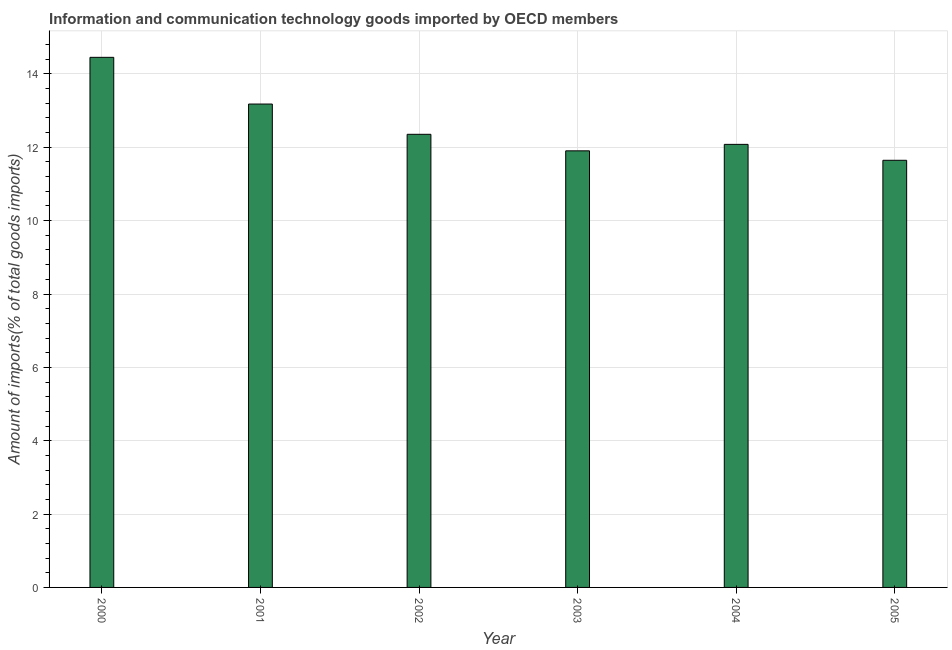Does the graph contain grids?
Offer a terse response. Yes. What is the title of the graph?
Give a very brief answer. Information and communication technology goods imported by OECD members. What is the label or title of the X-axis?
Provide a succinct answer. Year. What is the label or title of the Y-axis?
Keep it short and to the point. Amount of imports(% of total goods imports). What is the amount of ict goods imports in 2002?
Ensure brevity in your answer.  12.35. Across all years, what is the maximum amount of ict goods imports?
Give a very brief answer. 14.45. Across all years, what is the minimum amount of ict goods imports?
Make the answer very short. 11.65. In which year was the amount of ict goods imports maximum?
Provide a succinct answer. 2000. In which year was the amount of ict goods imports minimum?
Offer a terse response. 2005. What is the sum of the amount of ict goods imports?
Provide a short and direct response. 75.62. What is the difference between the amount of ict goods imports in 2001 and 2003?
Ensure brevity in your answer.  1.28. What is the average amount of ict goods imports per year?
Your answer should be compact. 12.6. What is the median amount of ict goods imports?
Your answer should be very brief. 12.22. What is the ratio of the amount of ict goods imports in 2002 to that in 2003?
Provide a short and direct response. 1.04. Is the difference between the amount of ict goods imports in 2002 and 2003 greater than the difference between any two years?
Offer a very short reply. No. What is the difference between the highest and the second highest amount of ict goods imports?
Your answer should be very brief. 1.27. What is the difference between the highest and the lowest amount of ict goods imports?
Offer a very short reply. 2.81. How many bars are there?
Offer a very short reply. 6. Are all the bars in the graph horizontal?
Give a very brief answer. No. How many years are there in the graph?
Your response must be concise. 6. Are the values on the major ticks of Y-axis written in scientific E-notation?
Ensure brevity in your answer.  No. What is the Amount of imports(% of total goods imports) of 2000?
Ensure brevity in your answer.  14.45. What is the Amount of imports(% of total goods imports) in 2001?
Your answer should be compact. 13.18. What is the Amount of imports(% of total goods imports) in 2002?
Keep it short and to the point. 12.35. What is the Amount of imports(% of total goods imports) of 2003?
Keep it short and to the point. 11.9. What is the Amount of imports(% of total goods imports) in 2004?
Make the answer very short. 12.08. What is the Amount of imports(% of total goods imports) in 2005?
Offer a very short reply. 11.65. What is the difference between the Amount of imports(% of total goods imports) in 2000 and 2001?
Give a very brief answer. 1.27. What is the difference between the Amount of imports(% of total goods imports) in 2000 and 2002?
Your response must be concise. 2.1. What is the difference between the Amount of imports(% of total goods imports) in 2000 and 2003?
Make the answer very short. 2.55. What is the difference between the Amount of imports(% of total goods imports) in 2000 and 2004?
Provide a succinct answer. 2.37. What is the difference between the Amount of imports(% of total goods imports) in 2000 and 2005?
Give a very brief answer. 2.81. What is the difference between the Amount of imports(% of total goods imports) in 2001 and 2002?
Give a very brief answer. 0.83. What is the difference between the Amount of imports(% of total goods imports) in 2001 and 2003?
Give a very brief answer. 1.28. What is the difference between the Amount of imports(% of total goods imports) in 2001 and 2004?
Your response must be concise. 1.1. What is the difference between the Amount of imports(% of total goods imports) in 2001 and 2005?
Ensure brevity in your answer.  1.53. What is the difference between the Amount of imports(% of total goods imports) in 2002 and 2003?
Offer a terse response. 0.45. What is the difference between the Amount of imports(% of total goods imports) in 2002 and 2004?
Your answer should be compact. 0.27. What is the difference between the Amount of imports(% of total goods imports) in 2002 and 2005?
Your answer should be very brief. 0.71. What is the difference between the Amount of imports(% of total goods imports) in 2003 and 2004?
Offer a terse response. -0.18. What is the difference between the Amount of imports(% of total goods imports) in 2003 and 2005?
Your response must be concise. 0.26. What is the difference between the Amount of imports(% of total goods imports) in 2004 and 2005?
Offer a terse response. 0.43. What is the ratio of the Amount of imports(% of total goods imports) in 2000 to that in 2001?
Make the answer very short. 1.1. What is the ratio of the Amount of imports(% of total goods imports) in 2000 to that in 2002?
Make the answer very short. 1.17. What is the ratio of the Amount of imports(% of total goods imports) in 2000 to that in 2003?
Make the answer very short. 1.21. What is the ratio of the Amount of imports(% of total goods imports) in 2000 to that in 2004?
Keep it short and to the point. 1.2. What is the ratio of the Amount of imports(% of total goods imports) in 2000 to that in 2005?
Provide a succinct answer. 1.24. What is the ratio of the Amount of imports(% of total goods imports) in 2001 to that in 2002?
Make the answer very short. 1.07. What is the ratio of the Amount of imports(% of total goods imports) in 2001 to that in 2003?
Your answer should be very brief. 1.11. What is the ratio of the Amount of imports(% of total goods imports) in 2001 to that in 2004?
Your answer should be compact. 1.09. What is the ratio of the Amount of imports(% of total goods imports) in 2001 to that in 2005?
Keep it short and to the point. 1.13. What is the ratio of the Amount of imports(% of total goods imports) in 2002 to that in 2003?
Keep it short and to the point. 1.04. What is the ratio of the Amount of imports(% of total goods imports) in 2002 to that in 2005?
Offer a terse response. 1.06. 